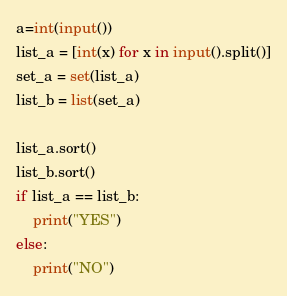<code> <loc_0><loc_0><loc_500><loc_500><_Python_>a=int(input())
list_a = [int(x) for x in input().split()]
set_a = set(list_a)
list_b = list(set_a)

list_a.sort()
list_b.sort()
if list_a == list_b:
    print("YES")
else:
    print("NO")</code> 